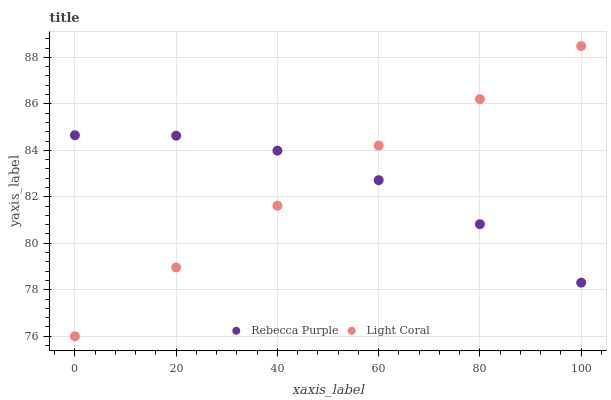Does Light Coral have the minimum area under the curve?
Answer yes or no. Yes. Does Rebecca Purple have the maximum area under the curve?
Answer yes or no. Yes. Does Rebecca Purple have the minimum area under the curve?
Answer yes or no. No. Is Light Coral the smoothest?
Answer yes or no. Yes. Is Rebecca Purple the roughest?
Answer yes or no. Yes. Is Rebecca Purple the smoothest?
Answer yes or no. No. Does Light Coral have the lowest value?
Answer yes or no. Yes. Does Rebecca Purple have the lowest value?
Answer yes or no. No. Does Light Coral have the highest value?
Answer yes or no. Yes. Does Rebecca Purple have the highest value?
Answer yes or no. No. Does Light Coral intersect Rebecca Purple?
Answer yes or no. Yes. Is Light Coral less than Rebecca Purple?
Answer yes or no. No. Is Light Coral greater than Rebecca Purple?
Answer yes or no. No. 